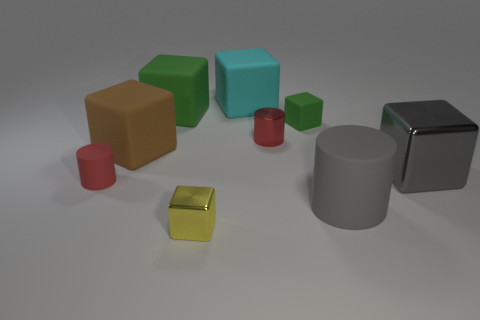There is a big green object that is the same shape as the large brown object; what is it made of?
Your response must be concise. Rubber. Is there a large matte block?
Provide a short and direct response. Yes. How big is the matte object that is in front of the gray metallic cube and on the left side of the cyan block?
Your response must be concise. Small. What is the shape of the small red rubber thing?
Provide a succinct answer. Cylinder. There is a large brown thing in front of the cyan matte block; is there a cylinder behind it?
Give a very brief answer. Yes. There is a gray cylinder that is the same size as the gray metallic thing; what material is it?
Ensure brevity in your answer.  Rubber. Is there a cyan object of the same size as the brown block?
Your answer should be compact. Yes. What is the red cylinder on the left side of the yellow metal object made of?
Your response must be concise. Rubber. Are the red thing in front of the big metal object and the big gray block made of the same material?
Offer a very short reply. No. What shape is the other gray object that is the same size as the gray rubber thing?
Ensure brevity in your answer.  Cube. 